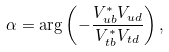<formula> <loc_0><loc_0><loc_500><loc_500>\alpha = \arg \left ( - \frac { V _ { u b } ^ { * } V _ { u d } } { V _ { t b } ^ { * } V _ { t d } } \right ) ,</formula> 